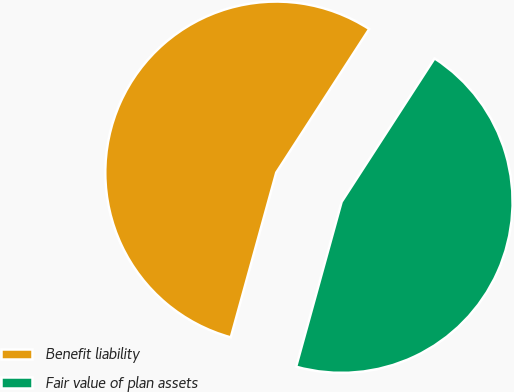Convert chart. <chart><loc_0><loc_0><loc_500><loc_500><pie_chart><fcel>Benefit liability<fcel>Fair value of plan assets<nl><fcel>54.86%<fcel>45.14%<nl></chart> 